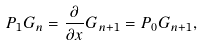<formula> <loc_0><loc_0><loc_500><loc_500>P _ { 1 } G _ { n } = \frac { \partial } { \partial x } G _ { n + 1 } = P _ { 0 } G _ { n + 1 } ,</formula> 